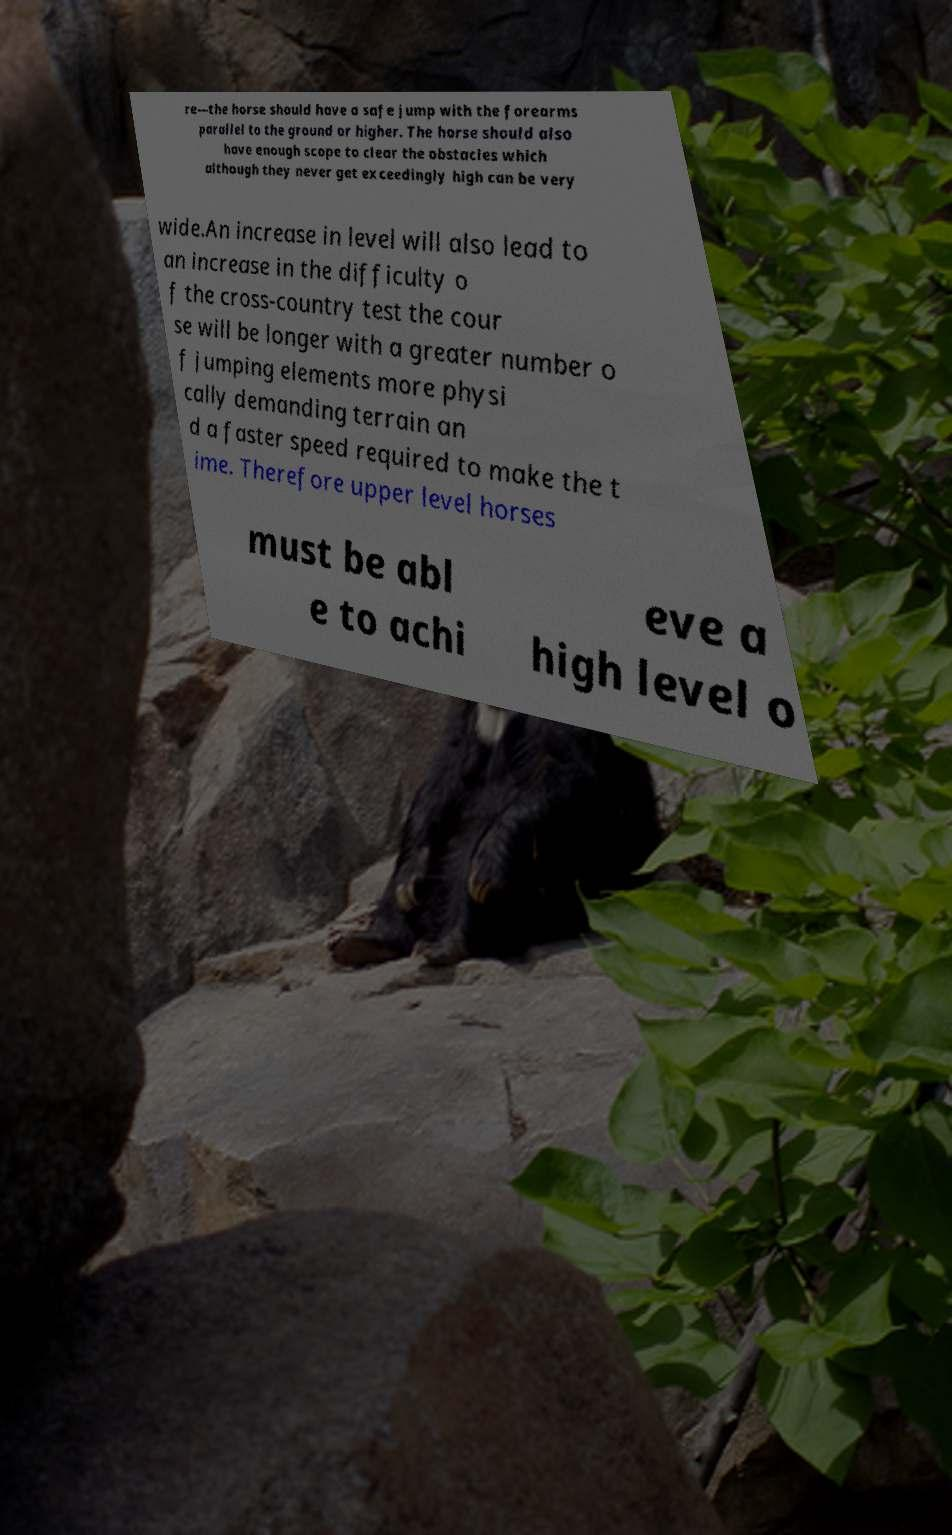I need the written content from this picture converted into text. Can you do that? re—the horse should have a safe jump with the forearms parallel to the ground or higher. The horse should also have enough scope to clear the obstacles which although they never get exceedingly high can be very wide.An increase in level will also lead to an increase in the difficulty o f the cross-country test the cour se will be longer with a greater number o f jumping elements more physi cally demanding terrain an d a faster speed required to make the t ime. Therefore upper level horses must be abl e to achi eve a high level o 